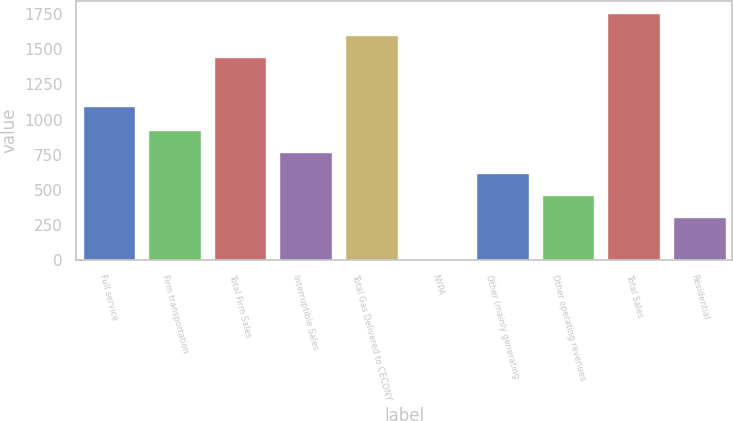<chart> <loc_0><loc_0><loc_500><loc_500><bar_chart><fcel>Full service<fcel>Firm transportation<fcel>Total Firm Sales<fcel>Interruptible Sales<fcel>Total Gas Delivered to CECONY<fcel>NYPA<fcel>Other (mainly generating<fcel>Other operating revenues<fcel>Total Sales<fcel>Residential<nl><fcel>1099<fcel>925.4<fcel>1446<fcel>771.5<fcel>1599.9<fcel>2<fcel>617.6<fcel>463.7<fcel>1753.8<fcel>309.8<nl></chart> 